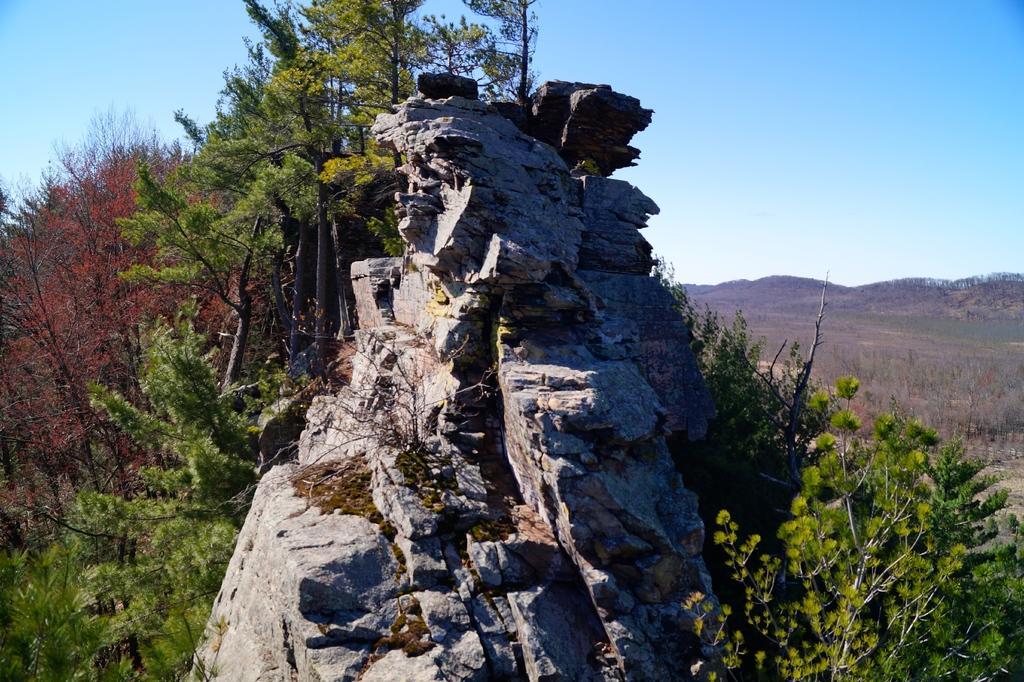Can you describe this image briefly? In this picture we can see rocks, trees, mountains, grass and in the background we can see the sky. 